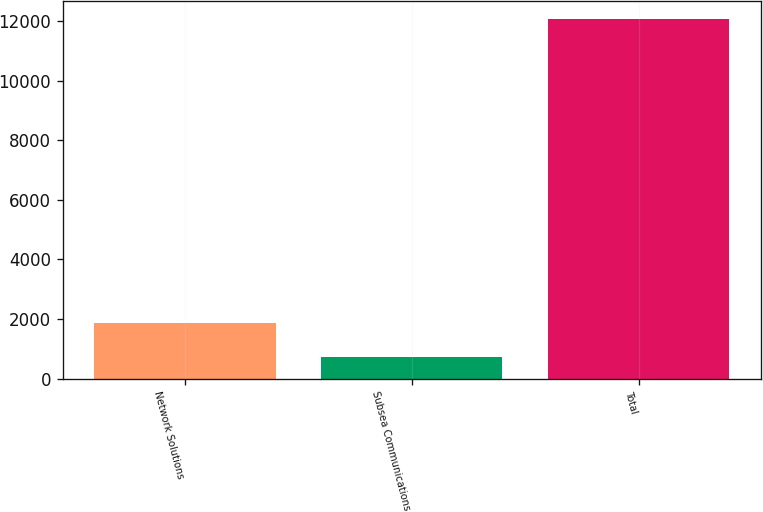Convert chart. <chart><loc_0><loc_0><loc_500><loc_500><bar_chart><fcel>Network Solutions<fcel>Subsea Communications<fcel>Total<nl><fcel>1858.6<fcel>724<fcel>12070<nl></chart> 